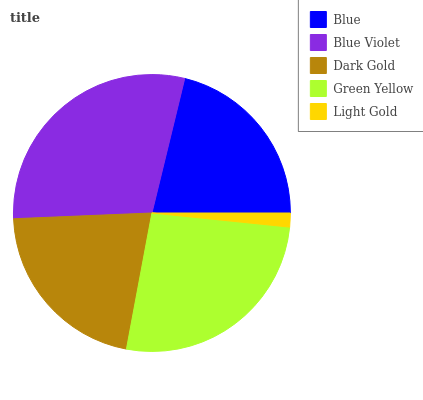Is Light Gold the minimum?
Answer yes or no. Yes. Is Blue Violet the maximum?
Answer yes or no. Yes. Is Dark Gold the minimum?
Answer yes or no. No. Is Dark Gold the maximum?
Answer yes or no. No. Is Blue Violet greater than Dark Gold?
Answer yes or no. Yes. Is Dark Gold less than Blue Violet?
Answer yes or no. Yes. Is Dark Gold greater than Blue Violet?
Answer yes or no. No. Is Blue Violet less than Dark Gold?
Answer yes or no. No. Is Dark Gold the high median?
Answer yes or no. Yes. Is Dark Gold the low median?
Answer yes or no. Yes. Is Green Yellow the high median?
Answer yes or no. No. Is Light Gold the low median?
Answer yes or no. No. 